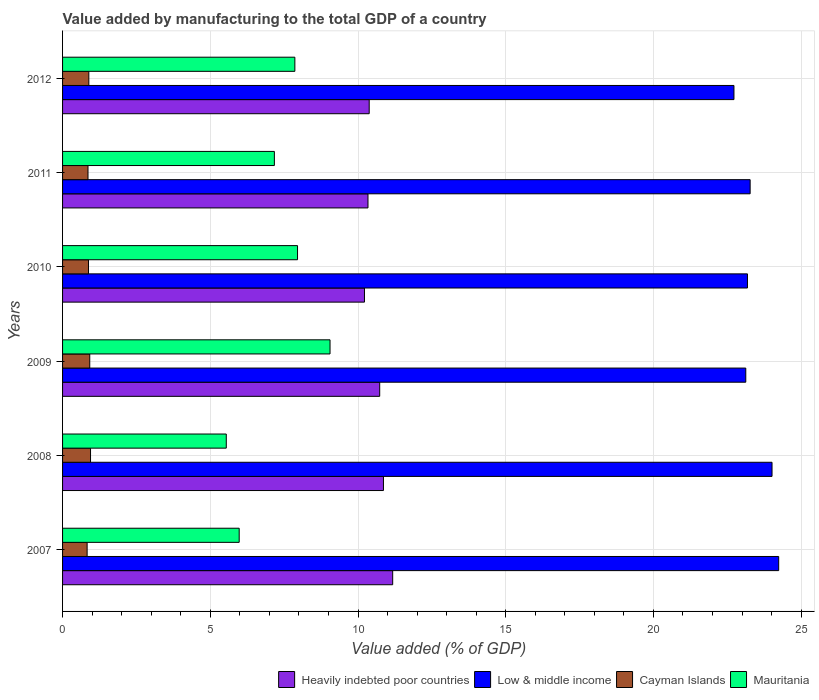How many groups of bars are there?
Your answer should be compact. 6. Are the number of bars on each tick of the Y-axis equal?
Your answer should be compact. Yes. How many bars are there on the 2nd tick from the top?
Ensure brevity in your answer.  4. What is the value added by manufacturing to the total GDP in Low & middle income in 2008?
Offer a very short reply. 24.01. Across all years, what is the maximum value added by manufacturing to the total GDP in Mauritania?
Keep it short and to the point. 9.05. Across all years, what is the minimum value added by manufacturing to the total GDP in Heavily indebted poor countries?
Give a very brief answer. 10.22. What is the total value added by manufacturing to the total GDP in Low & middle income in the graph?
Provide a short and direct response. 140.56. What is the difference between the value added by manufacturing to the total GDP in Mauritania in 2009 and that in 2011?
Your answer should be compact. 1.88. What is the difference between the value added by manufacturing to the total GDP in Low & middle income in 2010 and the value added by manufacturing to the total GDP in Heavily indebted poor countries in 2009?
Offer a very short reply. 12.45. What is the average value added by manufacturing to the total GDP in Low & middle income per year?
Provide a succinct answer. 23.43. In the year 2010, what is the difference between the value added by manufacturing to the total GDP in Cayman Islands and value added by manufacturing to the total GDP in Low & middle income?
Provide a short and direct response. -22.31. What is the ratio of the value added by manufacturing to the total GDP in Heavily indebted poor countries in 2007 to that in 2012?
Give a very brief answer. 1.08. Is the value added by manufacturing to the total GDP in Mauritania in 2007 less than that in 2012?
Your response must be concise. Yes. Is the difference between the value added by manufacturing to the total GDP in Cayman Islands in 2007 and 2010 greater than the difference between the value added by manufacturing to the total GDP in Low & middle income in 2007 and 2010?
Offer a terse response. No. What is the difference between the highest and the second highest value added by manufacturing to the total GDP in Mauritania?
Keep it short and to the point. 1.1. What is the difference between the highest and the lowest value added by manufacturing to the total GDP in Cayman Islands?
Your response must be concise. 0.12. Is it the case that in every year, the sum of the value added by manufacturing to the total GDP in Low & middle income and value added by manufacturing to the total GDP in Heavily indebted poor countries is greater than the sum of value added by manufacturing to the total GDP in Mauritania and value added by manufacturing to the total GDP in Cayman Islands?
Ensure brevity in your answer.  No. What does the 4th bar from the top in 2012 represents?
Keep it short and to the point. Heavily indebted poor countries. What does the 1st bar from the bottom in 2012 represents?
Keep it short and to the point. Heavily indebted poor countries. Are all the bars in the graph horizontal?
Provide a succinct answer. Yes. How many years are there in the graph?
Give a very brief answer. 6. Are the values on the major ticks of X-axis written in scientific E-notation?
Keep it short and to the point. No. Does the graph contain grids?
Your response must be concise. Yes. How are the legend labels stacked?
Provide a succinct answer. Horizontal. What is the title of the graph?
Provide a short and direct response. Value added by manufacturing to the total GDP of a country. Does "Nigeria" appear as one of the legend labels in the graph?
Offer a very short reply. No. What is the label or title of the X-axis?
Your response must be concise. Value added (% of GDP). What is the label or title of the Y-axis?
Offer a very short reply. Years. What is the Value added (% of GDP) of Heavily indebted poor countries in 2007?
Ensure brevity in your answer.  11.17. What is the Value added (% of GDP) in Low & middle income in 2007?
Your response must be concise. 24.24. What is the Value added (% of GDP) of Cayman Islands in 2007?
Give a very brief answer. 0.83. What is the Value added (% of GDP) of Mauritania in 2007?
Ensure brevity in your answer.  5.98. What is the Value added (% of GDP) of Heavily indebted poor countries in 2008?
Your answer should be compact. 10.86. What is the Value added (% of GDP) of Low & middle income in 2008?
Your response must be concise. 24.01. What is the Value added (% of GDP) in Cayman Islands in 2008?
Ensure brevity in your answer.  0.95. What is the Value added (% of GDP) of Mauritania in 2008?
Offer a terse response. 5.54. What is the Value added (% of GDP) of Heavily indebted poor countries in 2009?
Make the answer very short. 10.73. What is the Value added (% of GDP) in Low & middle income in 2009?
Offer a terse response. 23.13. What is the Value added (% of GDP) of Cayman Islands in 2009?
Offer a very short reply. 0.92. What is the Value added (% of GDP) in Mauritania in 2009?
Provide a short and direct response. 9.05. What is the Value added (% of GDP) of Heavily indebted poor countries in 2010?
Your answer should be very brief. 10.22. What is the Value added (% of GDP) of Low & middle income in 2010?
Keep it short and to the point. 23.18. What is the Value added (% of GDP) in Cayman Islands in 2010?
Your answer should be very brief. 0.88. What is the Value added (% of GDP) of Mauritania in 2010?
Provide a short and direct response. 7.95. What is the Value added (% of GDP) in Heavily indebted poor countries in 2011?
Your answer should be very brief. 10.34. What is the Value added (% of GDP) of Low & middle income in 2011?
Ensure brevity in your answer.  23.27. What is the Value added (% of GDP) in Cayman Islands in 2011?
Keep it short and to the point. 0.86. What is the Value added (% of GDP) of Mauritania in 2011?
Give a very brief answer. 7.17. What is the Value added (% of GDP) of Heavily indebted poor countries in 2012?
Your answer should be very brief. 10.38. What is the Value added (% of GDP) of Low & middle income in 2012?
Give a very brief answer. 22.73. What is the Value added (% of GDP) of Cayman Islands in 2012?
Provide a succinct answer. 0.89. What is the Value added (% of GDP) of Mauritania in 2012?
Your answer should be very brief. 7.86. Across all years, what is the maximum Value added (% of GDP) in Heavily indebted poor countries?
Your answer should be compact. 11.17. Across all years, what is the maximum Value added (% of GDP) in Low & middle income?
Offer a terse response. 24.24. Across all years, what is the maximum Value added (% of GDP) in Cayman Islands?
Provide a succinct answer. 0.95. Across all years, what is the maximum Value added (% of GDP) of Mauritania?
Offer a terse response. 9.05. Across all years, what is the minimum Value added (% of GDP) of Heavily indebted poor countries?
Your response must be concise. 10.22. Across all years, what is the minimum Value added (% of GDP) of Low & middle income?
Make the answer very short. 22.73. Across all years, what is the minimum Value added (% of GDP) in Cayman Islands?
Your response must be concise. 0.83. Across all years, what is the minimum Value added (% of GDP) in Mauritania?
Your answer should be compact. 5.54. What is the total Value added (% of GDP) in Heavily indebted poor countries in the graph?
Ensure brevity in your answer.  63.71. What is the total Value added (% of GDP) of Low & middle income in the graph?
Keep it short and to the point. 140.56. What is the total Value added (% of GDP) of Cayman Islands in the graph?
Make the answer very short. 5.33. What is the total Value added (% of GDP) of Mauritania in the graph?
Keep it short and to the point. 43.56. What is the difference between the Value added (% of GDP) in Heavily indebted poor countries in 2007 and that in 2008?
Make the answer very short. 0.31. What is the difference between the Value added (% of GDP) in Low & middle income in 2007 and that in 2008?
Your answer should be compact. 0.23. What is the difference between the Value added (% of GDP) in Cayman Islands in 2007 and that in 2008?
Ensure brevity in your answer.  -0.12. What is the difference between the Value added (% of GDP) in Mauritania in 2007 and that in 2008?
Your answer should be very brief. 0.44. What is the difference between the Value added (% of GDP) in Heavily indebted poor countries in 2007 and that in 2009?
Ensure brevity in your answer.  0.44. What is the difference between the Value added (% of GDP) in Low & middle income in 2007 and that in 2009?
Ensure brevity in your answer.  1.11. What is the difference between the Value added (% of GDP) in Cayman Islands in 2007 and that in 2009?
Make the answer very short. -0.09. What is the difference between the Value added (% of GDP) in Mauritania in 2007 and that in 2009?
Your answer should be compact. -3.08. What is the difference between the Value added (% of GDP) in Heavily indebted poor countries in 2007 and that in 2010?
Your answer should be compact. 0.96. What is the difference between the Value added (% of GDP) in Low & middle income in 2007 and that in 2010?
Keep it short and to the point. 1.06. What is the difference between the Value added (% of GDP) in Cayman Islands in 2007 and that in 2010?
Keep it short and to the point. -0.05. What is the difference between the Value added (% of GDP) in Mauritania in 2007 and that in 2010?
Offer a terse response. -1.97. What is the difference between the Value added (% of GDP) of Heavily indebted poor countries in 2007 and that in 2011?
Offer a very short reply. 0.84. What is the difference between the Value added (% of GDP) in Low & middle income in 2007 and that in 2011?
Ensure brevity in your answer.  0.97. What is the difference between the Value added (% of GDP) of Cayman Islands in 2007 and that in 2011?
Your response must be concise. -0.03. What is the difference between the Value added (% of GDP) of Mauritania in 2007 and that in 2011?
Give a very brief answer. -1.19. What is the difference between the Value added (% of GDP) of Heavily indebted poor countries in 2007 and that in 2012?
Offer a terse response. 0.8. What is the difference between the Value added (% of GDP) in Low & middle income in 2007 and that in 2012?
Provide a short and direct response. 1.51. What is the difference between the Value added (% of GDP) of Cayman Islands in 2007 and that in 2012?
Offer a very short reply. -0.06. What is the difference between the Value added (% of GDP) of Mauritania in 2007 and that in 2012?
Your answer should be compact. -1.88. What is the difference between the Value added (% of GDP) in Heavily indebted poor countries in 2008 and that in 2009?
Provide a succinct answer. 0.13. What is the difference between the Value added (% of GDP) of Low & middle income in 2008 and that in 2009?
Keep it short and to the point. 0.89. What is the difference between the Value added (% of GDP) of Cayman Islands in 2008 and that in 2009?
Give a very brief answer. 0.03. What is the difference between the Value added (% of GDP) in Mauritania in 2008 and that in 2009?
Provide a succinct answer. -3.51. What is the difference between the Value added (% of GDP) in Heavily indebted poor countries in 2008 and that in 2010?
Give a very brief answer. 0.64. What is the difference between the Value added (% of GDP) in Low & middle income in 2008 and that in 2010?
Your answer should be very brief. 0.83. What is the difference between the Value added (% of GDP) of Cayman Islands in 2008 and that in 2010?
Provide a succinct answer. 0.07. What is the difference between the Value added (% of GDP) of Mauritania in 2008 and that in 2010?
Keep it short and to the point. -2.41. What is the difference between the Value added (% of GDP) in Heavily indebted poor countries in 2008 and that in 2011?
Your answer should be compact. 0.52. What is the difference between the Value added (% of GDP) of Low & middle income in 2008 and that in 2011?
Provide a succinct answer. 0.74. What is the difference between the Value added (% of GDP) of Cayman Islands in 2008 and that in 2011?
Ensure brevity in your answer.  0.09. What is the difference between the Value added (% of GDP) in Mauritania in 2008 and that in 2011?
Ensure brevity in your answer.  -1.63. What is the difference between the Value added (% of GDP) of Heavily indebted poor countries in 2008 and that in 2012?
Ensure brevity in your answer.  0.48. What is the difference between the Value added (% of GDP) in Low & middle income in 2008 and that in 2012?
Provide a short and direct response. 1.29. What is the difference between the Value added (% of GDP) of Cayman Islands in 2008 and that in 2012?
Your answer should be very brief. 0.06. What is the difference between the Value added (% of GDP) in Mauritania in 2008 and that in 2012?
Give a very brief answer. -2.32. What is the difference between the Value added (% of GDP) in Heavily indebted poor countries in 2009 and that in 2010?
Provide a succinct answer. 0.52. What is the difference between the Value added (% of GDP) in Low & middle income in 2009 and that in 2010?
Offer a terse response. -0.06. What is the difference between the Value added (% of GDP) in Cayman Islands in 2009 and that in 2010?
Keep it short and to the point. 0.04. What is the difference between the Value added (% of GDP) in Mauritania in 2009 and that in 2010?
Offer a terse response. 1.1. What is the difference between the Value added (% of GDP) of Heavily indebted poor countries in 2009 and that in 2011?
Keep it short and to the point. 0.4. What is the difference between the Value added (% of GDP) of Low & middle income in 2009 and that in 2011?
Offer a terse response. -0.15. What is the difference between the Value added (% of GDP) in Cayman Islands in 2009 and that in 2011?
Your answer should be very brief. 0.06. What is the difference between the Value added (% of GDP) in Mauritania in 2009 and that in 2011?
Your answer should be compact. 1.88. What is the difference between the Value added (% of GDP) in Heavily indebted poor countries in 2009 and that in 2012?
Provide a short and direct response. 0.36. What is the difference between the Value added (% of GDP) in Low & middle income in 2009 and that in 2012?
Offer a very short reply. 0.4. What is the difference between the Value added (% of GDP) in Cayman Islands in 2009 and that in 2012?
Offer a very short reply. 0.03. What is the difference between the Value added (% of GDP) of Mauritania in 2009 and that in 2012?
Offer a terse response. 1.19. What is the difference between the Value added (% of GDP) of Heavily indebted poor countries in 2010 and that in 2011?
Ensure brevity in your answer.  -0.12. What is the difference between the Value added (% of GDP) in Low & middle income in 2010 and that in 2011?
Offer a very short reply. -0.09. What is the difference between the Value added (% of GDP) of Cayman Islands in 2010 and that in 2011?
Keep it short and to the point. 0.02. What is the difference between the Value added (% of GDP) of Mauritania in 2010 and that in 2011?
Ensure brevity in your answer.  0.78. What is the difference between the Value added (% of GDP) of Heavily indebted poor countries in 2010 and that in 2012?
Ensure brevity in your answer.  -0.16. What is the difference between the Value added (% of GDP) in Low & middle income in 2010 and that in 2012?
Give a very brief answer. 0.46. What is the difference between the Value added (% of GDP) in Cayman Islands in 2010 and that in 2012?
Give a very brief answer. -0.01. What is the difference between the Value added (% of GDP) of Mauritania in 2010 and that in 2012?
Give a very brief answer. 0.09. What is the difference between the Value added (% of GDP) in Heavily indebted poor countries in 2011 and that in 2012?
Your response must be concise. -0.04. What is the difference between the Value added (% of GDP) in Low & middle income in 2011 and that in 2012?
Keep it short and to the point. 0.55. What is the difference between the Value added (% of GDP) in Cayman Islands in 2011 and that in 2012?
Provide a short and direct response. -0.03. What is the difference between the Value added (% of GDP) in Mauritania in 2011 and that in 2012?
Make the answer very short. -0.69. What is the difference between the Value added (% of GDP) in Heavily indebted poor countries in 2007 and the Value added (% of GDP) in Low & middle income in 2008?
Give a very brief answer. -12.84. What is the difference between the Value added (% of GDP) in Heavily indebted poor countries in 2007 and the Value added (% of GDP) in Cayman Islands in 2008?
Provide a succinct answer. 10.23. What is the difference between the Value added (% of GDP) of Heavily indebted poor countries in 2007 and the Value added (% of GDP) of Mauritania in 2008?
Your response must be concise. 5.63. What is the difference between the Value added (% of GDP) in Low & middle income in 2007 and the Value added (% of GDP) in Cayman Islands in 2008?
Make the answer very short. 23.29. What is the difference between the Value added (% of GDP) in Low & middle income in 2007 and the Value added (% of GDP) in Mauritania in 2008?
Offer a terse response. 18.7. What is the difference between the Value added (% of GDP) in Cayman Islands in 2007 and the Value added (% of GDP) in Mauritania in 2008?
Offer a very short reply. -4.71. What is the difference between the Value added (% of GDP) in Heavily indebted poor countries in 2007 and the Value added (% of GDP) in Low & middle income in 2009?
Provide a succinct answer. -11.95. What is the difference between the Value added (% of GDP) of Heavily indebted poor countries in 2007 and the Value added (% of GDP) of Cayman Islands in 2009?
Your response must be concise. 10.25. What is the difference between the Value added (% of GDP) in Heavily indebted poor countries in 2007 and the Value added (% of GDP) in Mauritania in 2009?
Offer a very short reply. 2.12. What is the difference between the Value added (% of GDP) in Low & middle income in 2007 and the Value added (% of GDP) in Cayman Islands in 2009?
Your answer should be compact. 23.32. What is the difference between the Value added (% of GDP) in Low & middle income in 2007 and the Value added (% of GDP) in Mauritania in 2009?
Make the answer very short. 15.19. What is the difference between the Value added (% of GDP) of Cayman Islands in 2007 and the Value added (% of GDP) of Mauritania in 2009?
Give a very brief answer. -8.22. What is the difference between the Value added (% of GDP) in Heavily indebted poor countries in 2007 and the Value added (% of GDP) in Low & middle income in 2010?
Keep it short and to the point. -12.01. What is the difference between the Value added (% of GDP) in Heavily indebted poor countries in 2007 and the Value added (% of GDP) in Cayman Islands in 2010?
Your answer should be very brief. 10.3. What is the difference between the Value added (% of GDP) of Heavily indebted poor countries in 2007 and the Value added (% of GDP) of Mauritania in 2010?
Your answer should be compact. 3.22. What is the difference between the Value added (% of GDP) in Low & middle income in 2007 and the Value added (% of GDP) in Cayman Islands in 2010?
Your answer should be very brief. 23.36. What is the difference between the Value added (% of GDP) of Low & middle income in 2007 and the Value added (% of GDP) of Mauritania in 2010?
Ensure brevity in your answer.  16.29. What is the difference between the Value added (% of GDP) of Cayman Islands in 2007 and the Value added (% of GDP) of Mauritania in 2010?
Give a very brief answer. -7.12. What is the difference between the Value added (% of GDP) in Heavily indebted poor countries in 2007 and the Value added (% of GDP) in Low & middle income in 2011?
Keep it short and to the point. -12.1. What is the difference between the Value added (% of GDP) of Heavily indebted poor countries in 2007 and the Value added (% of GDP) of Cayman Islands in 2011?
Give a very brief answer. 10.31. What is the difference between the Value added (% of GDP) in Heavily indebted poor countries in 2007 and the Value added (% of GDP) in Mauritania in 2011?
Your answer should be very brief. 4.01. What is the difference between the Value added (% of GDP) in Low & middle income in 2007 and the Value added (% of GDP) in Cayman Islands in 2011?
Provide a succinct answer. 23.38. What is the difference between the Value added (% of GDP) of Low & middle income in 2007 and the Value added (% of GDP) of Mauritania in 2011?
Offer a terse response. 17.07. What is the difference between the Value added (% of GDP) of Cayman Islands in 2007 and the Value added (% of GDP) of Mauritania in 2011?
Provide a succinct answer. -6.34. What is the difference between the Value added (% of GDP) of Heavily indebted poor countries in 2007 and the Value added (% of GDP) of Low & middle income in 2012?
Give a very brief answer. -11.55. What is the difference between the Value added (% of GDP) in Heavily indebted poor countries in 2007 and the Value added (% of GDP) in Cayman Islands in 2012?
Provide a succinct answer. 10.29. What is the difference between the Value added (% of GDP) in Heavily indebted poor countries in 2007 and the Value added (% of GDP) in Mauritania in 2012?
Ensure brevity in your answer.  3.31. What is the difference between the Value added (% of GDP) of Low & middle income in 2007 and the Value added (% of GDP) of Cayman Islands in 2012?
Provide a short and direct response. 23.35. What is the difference between the Value added (% of GDP) in Low & middle income in 2007 and the Value added (% of GDP) in Mauritania in 2012?
Offer a terse response. 16.38. What is the difference between the Value added (% of GDP) in Cayman Islands in 2007 and the Value added (% of GDP) in Mauritania in 2012?
Your response must be concise. -7.03. What is the difference between the Value added (% of GDP) in Heavily indebted poor countries in 2008 and the Value added (% of GDP) in Low & middle income in 2009?
Offer a very short reply. -12.26. What is the difference between the Value added (% of GDP) of Heavily indebted poor countries in 2008 and the Value added (% of GDP) of Cayman Islands in 2009?
Offer a very short reply. 9.94. What is the difference between the Value added (% of GDP) of Heavily indebted poor countries in 2008 and the Value added (% of GDP) of Mauritania in 2009?
Give a very brief answer. 1.81. What is the difference between the Value added (% of GDP) of Low & middle income in 2008 and the Value added (% of GDP) of Cayman Islands in 2009?
Your answer should be very brief. 23.09. What is the difference between the Value added (% of GDP) of Low & middle income in 2008 and the Value added (% of GDP) of Mauritania in 2009?
Your answer should be very brief. 14.96. What is the difference between the Value added (% of GDP) in Cayman Islands in 2008 and the Value added (% of GDP) in Mauritania in 2009?
Ensure brevity in your answer.  -8.11. What is the difference between the Value added (% of GDP) of Heavily indebted poor countries in 2008 and the Value added (% of GDP) of Low & middle income in 2010?
Provide a short and direct response. -12.32. What is the difference between the Value added (% of GDP) in Heavily indebted poor countries in 2008 and the Value added (% of GDP) in Cayman Islands in 2010?
Offer a very short reply. 9.98. What is the difference between the Value added (% of GDP) in Heavily indebted poor countries in 2008 and the Value added (% of GDP) in Mauritania in 2010?
Provide a succinct answer. 2.91. What is the difference between the Value added (% of GDP) of Low & middle income in 2008 and the Value added (% of GDP) of Cayman Islands in 2010?
Keep it short and to the point. 23.14. What is the difference between the Value added (% of GDP) in Low & middle income in 2008 and the Value added (% of GDP) in Mauritania in 2010?
Make the answer very short. 16.06. What is the difference between the Value added (% of GDP) of Cayman Islands in 2008 and the Value added (% of GDP) of Mauritania in 2010?
Your answer should be very brief. -7.01. What is the difference between the Value added (% of GDP) of Heavily indebted poor countries in 2008 and the Value added (% of GDP) of Low & middle income in 2011?
Offer a very short reply. -12.41. What is the difference between the Value added (% of GDP) of Heavily indebted poor countries in 2008 and the Value added (% of GDP) of Cayman Islands in 2011?
Make the answer very short. 10. What is the difference between the Value added (% of GDP) of Heavily indebted poor countries in 2008 and the Value added (% of GDP) of Mauritania in 2011?
Your response must be concise. 3.69. What is the difference between the Value added (% of GDP) in Low & middle income in 2008 and the Value added (% of GDP) in Cayman Islands in 2011?
Your response must be concise. 23.15. What is the difference between the Value added (% of GDP) of Low & middle income in 2008 and the Value added (% of GDP) of Mauritania in 2011?
Make the answer very short. 16.84. What is the difference between the Value added (% of GDP) in Cayman Islands in 2008 and the Value added (% of GDP) in Mauritania in 2011?
Ensure brevity in your answer.  -6.22. What is the difference between the Value added (% of GDP) in Heavily indebted poor countries in 2008 and the Value added (% of GDP) in Low & middle income in 2012?
Your response must be concise. -11.86. What is the difference between the Value added (% of GDP) of Heavily indebted poor countries in 2008 and the Value added (% of GDP) of Cayman Islands in 2012?
Ensure brevity in your answer.  9.97. What is the difference between the Value added (% of GDP) in Heavily indebted poor countries in 2008 and the Value added (% of GDP) in Mauritania in 2012?
Keep it short and to the point. 3. What is the difference between the Value added (% of GDP) in Low & middle income in 2008 and the Value added (% of GDP) in Cayman Islands in 2012?
Give a very brief answer. 23.12. What is the difference between the Value added (% of GDP) of Low & middle income in 2008 and the Value added (% of GDP) of Mauritania in 2012?
Your response must be concise. 16.15. What is the difference between the Value added (% of GDP) in Cayman Islands in 2008 and the Value added (% of GDP) in Mauritania in 2012?
Provide a short and direct response. -6.92. What is the difference between the Value added (% of GDP) of Heavily indebted poor countries in 2009 and the Value added (% of GDP) of Low & middle income in 2010?
Ensure brevity in your answer.  -12.45. What is the difference between the Value added (% of GDP) of Heavily indebted poor countries in 2009 and the Value added (% of GDP) of Cayman Islands in 2010?
Make the answer very short. 9.86. What is the difference between the Value added (% of GDP) of Heavily indebted poor countries in 2009 and the Value added (% of GDP) of Mauritania in 2010?
Provide a succinct answer. 2.78. What is the difference between the Value added (% of GDP) in Low & middle income in 2009 and the Value added (% of GDP) in Cayman Islands in 2010?
Offer a very short reply. 22.25. What is the difference between the Value added (% of GDP) of Low & middle income in 2009 and the Value added (% of GDP) of Mauritania in 2010?
Your answer should be compact. 15.17. What is the difference between the Value added (% of GDP) in Cayman Islands in 2009 and the Value added (% of GDP) in Mauritania in 2010?
Keep it short and to the point. -7.03. What is the difference between the Value added (% of GDP) of Heavily indebted poor countries in 2009 and the Value added (% of GDP) of Low & middle income in 2011?
Give a very brief answer. -12.54. What is the difference between the Value added (% of GDP) in Heavily indebted poor countries in 2009 and the Value added (% of GDP) in Cayman Islands in 2011?
Your answer should be compact. 9.87. What is the difference between the Value added (% of GDP) in Heavily indebted poor countries in 2009 and the Value added (% of GDP) in Mauritania in 2011?
Offer a very short reply. 3.57. What is the difference between the Value added (% of GDP) in Low & middle income in 2009 and the Value added (% of GDP) in Cayman Islands in 2011?
Your answer should be compact. 22.27. What is the difference between the Value added (% of GDP) in Low & middle income in 2009 and the Value added (% of GDP) in Mauritania in 2011?
Provide a short and direct response. 15.96. What is the difference between the Value added (% of GDP) of Cayman Islands in 2009 and the Value added (% of GDP) of Mauritania in 2011?
Your response must be concise. -6.25. What is the difference between the Value added (% of GDP) of Heavily indebted poor countries in 2009 and the Value added (% of GDP) of Low & middle income in 2012?
Your answer should be compact. -11.99. What is the difference between the Value added (% of GDP) in Heavily indebted poor countries in 2009 and the Value added (% of GDP) in Cayman Islands in 2012?
Offer a very short reply. 9.85. What is the difference between the Value added (% of GDP) in Heavily indebted poor countries in 2009 and the Value added (% of GDP) in Mauritania in 2012?
Give a very brief answer. 2.87. What is the difference between the Value added (% of GDP) of Low & middle income in 2009 and the Value added (% of GDP) of Cayman Islands in 2012?
Make the answer very short. 22.24. What is the difference between the Value added (% of GDP) in Low & middle income in 2009 and the Value added (% of GDP) in Mauritania in 2012?
Provide a succinct answer. 15.26. What is the difference between the Value added (% of GDP) of Cayman Islands in 2009 and the Value added (% of GDP) of Mauritania in 2012?
Ensure brevity in your answer.  -6.94. What is the difference between the Value added (% of GDP) of Heavily indebted poor countries in 2010 and the Value added (% of GDP) of Low & middle income in 2011?
Offer a terse response. -13.05. What is the difference between the Value added (% of GDP) of Heavily indebted poor countries in 2010 and the Value added (% of GDP) of Cayman Islands in 2011?
Your answer should be very brief. 9.36. What is the difference between the Value added (% of GDP) of Heavily indebted poor countries in 2010 and the Value added (% of GDP) of Mauritania in 2011?
Provide a short and direct response. 3.05. What is the difference between the Value added (% of GDP) of Low & middle income in 2010 and the Value added (% of GDP) of Cayman Islands in 2011?
Provide a succinct answer. 22.32. What is the difference between the Value added (% of GDP) of Low & middle income in 2010 and the Value added (% of GDP) of Mauritania in 2011?
Your answer should be compact. 16.01. What is the difference between the Value added (% of GDP) of Cayman Islands in 2010 and the Value added (% of GDP) of Mauritania in 2011?
Provide a succinct answer. -6.29. What is the difference between the Value added (% of GDP) in Heavily indebted poor countries in 2010 and the Value added (% of GDP) in Low & middle income in 2012?
Provide a succinct answer. -12.51. What is the difference between the Value added (% of GDP) of Heavily indebted poor countries in 2010 and the Value added (% of GDP) of Cayman Islands in 2012?
Give a very brief answer. 9.33. What is the difference between the Value added (% of GDP) of Heavily indebted poor countries in 2010 and the Value added (% of GDP) of Mauritania in 2012?
Your answer should be compact. 2.36. What is the difference between the Value added (% of GDP) in Low & middle income in 2010 and the Value added (% of GDP) in Cayman Islands in 2012?
Ensure brevity in your answer.  22.29. What is the difference between the Value added (% of GDP) in Low & middle income in 2010 and the Value added (% of GDP) in Mauritania in 2012?
Offer a terse response. 15.32. What is the difference between the Value added (% of GDP) in Cayman Islands in 2010 and the Value added (% of GDP) in Mauritania in 2012?
Keep it short and to the point. -6.99. What is the difference between the Value added (% of GDP) in Heavily indebted poor countries in 2011 and the Value added (% of GDP) in Low & middle income in 2012?
Your answer should be very brief. -12.39. What is the difference between the Value added (% of GDP) of Heavily indebted poor countries in 2011 and the Value added (% of GDP) of Cayman Islands in 2012?
Ensure brevity in your answer.  9.45. What is the difference between the Value added (% of GDP) of Heavily indebted poor countries in 2011 and the Value added (% of GDP) of Mauritania in 2012?
Make the answer very short. 2.48. What is the difference between the Value added (% of GDP) in Low & middle income in 2011 and the Value added (% of GDP) in Cayman Islands in 2012?
Keep it short and to the point. 22.38. What is the difference between the Value added (% of GDP) in Low & middle income in 2011 and the Value added (% of GDP) in Mauritania in 2012?
Your answer should be compact. 15.41. What is the difference between the Value added (% of GDP) of Cayman Islands in 2011 and the Value added (% of GDP) of Mauritania in 2012?
Provide a short and direct response. -7. What is the average Value added (% of GDP) in Heavily indebted poor countries per year?
Your response must be concise. 10.62. What is the average Value added (% of GDP) in Low & middle income per year?
Give a very brief answer. 23.43. What is the average Value added (% of GDP) of Cayman Islands per year?
Keep it short and to the point. 0.89. What is the average Value added (% of GDP) of Mauritania per year?
Make the answer very short. 7.26. In the year 2007, what is the difference between the Value added (% of GDP) in Heavily indebted poor countries and Value added (% of GDP) in Low & middle income?
Make the answer very short. -13.07. In the year 2007, what is the difference between the Value added (% of GDP) in Heavily indebted poor countries and Value added (% of GDP) in Cayman Islands?
Provide a succinct answer. 10.34. In the year 2007, what is the difference between the Value added (% of GDP) in Heavily indebted poor countries and Value added (% of GDP) in Mauritania?
Give a very brief answer. 5.2. In the year 2007, what is the difference between the Value added (% of GDP) in Low & middle income and Value added (% of GDP) in Cayman Islands?
Offer a very short reply. 23.41. In the year 2007, what is the difference between the Value added (% of GDP) of Low & middle income and Value added (% of GDP) of Mauritania?
Keep it short and to the point. 18.26. In the year 2007, what is the difference between the Value added (% of GDP) in Cayman Islands and Value added (% of GDP) in Mauritania?
Offer a very short reply. -5.15. In the year 2008, what is the difference between the Value added (% of GDP) of Heavily indebted poor countries and Value added (% of GDP) of Low & middle income?
Your response must be concise. -13.15. In the year 2008, what is the difference between the Value added (% of GDP) in Heavily indebted poor countries and Value added (% of GDP) in Cayman Islands?
Provide a short and direct response. 9.91. In the year 2008, what is the difference between the Value added (% of GDP) of Heavily indebted poor countries and Value added (% of GDP) of Mauritania?
Keep it short and to the point. 5.32. In the year 2008, what is the difference between the Value added (% of GDP) of Low & middle income and Value added (% of GDP) of Cayman Islands?
Offer a very short reply. 23.07. In the year 2008, what is the difference between the Value added (% of GDP) of Low & middle income and Value added (% of GDP) of Mauritania?
Keep it short and to the point. 18.47. In the year 2008, what is the difference between the Value added (% of GDP) of Cayman Islands and Value added (% of GDP) of Mauritania?
Provide a short and direct response. -4.59. In the year 2009, what is the difference between the Value added (% of GDP) in Heavily indebted poor countries and Value added (% of GDP) in Low & middle income?
Offer a very short reply. -12.39. In the year 2009, what is the difference between the Value added (% of GDP) in Heavily indebted poor countries and Value added (% of GDP) in Cayman Islands?
Offer a terse response. 9.81. In the year 2009, what is the difference between the Value added (% of GDP) of Heavily indebted poor countries and Value added (% of GDP) of Mauritania?
Offer a very short reply. 1.68. In the year 2009, what is the difference between the Value added (% of GDP) of Low & middle income and Value added (% of GDP) of Cayman Islands?
Make the answer very short. 22.21. In the year 2009, what is the difference between the Value added (% of GDP) in Low & middle income and Value added (% of GDP) in Mauritania?
Provide a short and direct response. 14.07. In the year 2009, what is the difference between the Value added (% of GDP) of Cayman Islands and Value added (% of GDP) of Mauritania?
Your answer should be compact. -8.13. In the year 2010, what is the difference between the Value added (% of GDP) in Heavily indebted poor countries and Value added (% of GDP) in Low & middle income?
Offer a terse response. -12.96. In the year 2010, what is the difference between the Value added (% of GDP) of Heavily indebted poor countries and Value added (% of GDP) of Cayman Islands?
Make the answer very short. 9.34. In the year 2010, what is the difference between the Value added (% of GDP) in Heavily indebted poor countries and Value added (% of GDP) in Mauritania?
Offer a terse response. 2.27. In the year 2010, what is the difference between the Value added (% of GDP) in Low & middle income and Value added (% of GDP) in Cayman Islands?
Keep it short and to the point. 22.31. In the year 2010, what is the difference between the Value added (% of GDP) in Low & middle income and Value added (% of GDP) in Mauritania?
Offer a terse response. 15.23. In the year 2010, what is the difference between the Value added (% of GDP) in Cayman Islands and Value added (% of GDP) in Mauritania?
Keep it short and to the point. -7.08. In the year 2011, what is the difference between the Value added (% of GDP) of Heavily indebted poor countries and Value added (% of GDP) of Low & middle income?
Provide a short and direct response. -12.94. In the year 2011, what is the difference between the Value added (% of GDP) of Heavily indebted poor countries and Value added (% of GDP) of Cayman Islands?
Provide a short and direct response. 9.48. In the year 2011, what is the difference between the Value added (% of GDP) in Heavily indebted poor countries and Value added (% of GDP) in Mauritania?
Keep it short and to the point. 3.17. In the year 2011, what is the difference between the Value added (% of GDP) of Low & middle income and Value added (% of GDP) of Cayman Islands?
Your response must be concise. 22.41. In the year 2011, what is the difference between the Value added (% of GDP) in Low & middle income and Value added (% of GDP) in Mauritania?
Provide a succinct answer. 16.1. In the year 2011, what is the difference between the Value added (% of GDP) of Cayman Islands and Value added (% of GDP) of Mauritania?
Your answer should be very brief. -6.31. In the year 2012, what is the difference between the Value added (% of GDP) in Heavily indebted poor countries and Value added (% of GDP) in Low & middle income?
Give a very brief answer. -12.35. In the year 2012, what is the difference between the Value added (% of GDP) in Heavily indebted poor countries and Value added (% of GDP) in Cayman Islands?
Keep it short and to the point. 9.49. In the year 2012, what is the difference between the Value added (% of GDP) of Heavily indebted poor countries and Value added (% of GDP) of Mauritania?
Provide a short and direct response. 2.52. In the year 2012, what is the difference between the Value added (% of GDP) of Low & middle income and Value added (% of GDP) of Cayman Islands?
Ensure brevity in your answer.  21.84. In the year 2012, what is the difference between the Value added (% of GDP) in Low & middle income and Value added (% of GDP) in Mauritania?
Your response must be concise. 14.86. In the year 2012, what is the difference between the Value added (% of GDP) in Cayman Islands and Value added (% of GDP) in Mauritania?
Your answer should be compact. -6.97. What is the ratio of the Value added (% of GDP) in Heavily indebted poor countries in 2007 to that in 2008?
Provide a succinct answer. 1.03. What is the ratio of the Value added (% of GDP) in Low & middle income in 2007 to that in 2008?
Keep it short and to the point. 1.01. What is the ratio of the Value added (% of GDP) of Cayman Islands in 2007 to that in 2008?
Offer a very short reply. 0.88. What is the ratio of the Value added (% of GDP) of Mauritania in 2007 to that in 2008?
Ensure brevity in your answer.  1.08. What is the ratio of the Value added (% of GDP) in Heavily indebted poor countries in 2007 to that in 2009?
Ensure brevity in your answer.  1.04. What is the ratio of the Value added (% of GDP) of Low & middle income in 2007 to that in 2009?
Your answer should be compact. 1.05. What is the ratio of the Value added (% of GDP) in Cayman Islands in 2007 to that in 2009?
Give a very brief answer. 0.9. What is the ratio of the Value added (% of GDP) in Mauritania in 2007 to that in 2009?
Make the answer very short. 0.66. What is the ratio of the Value added (% of GDP) of Heavily indebted poor countries in 2007 to that in 2010?
Ensure brevity in your answer.  1.09. What is the ratio of the Value added (% of GDP) of Low & middle income in 2007 to that in 2010?
Your response must be concise. 1.05. What is the ratio of the Value added (% of GDP) in Cayman Islands in 2007 to that in 2010?
Ensure brevity in your answer.  0.95. What is the ratio of the Value added (% of GDP) in Mauritania in 2007 to that in 2010?
Offer a terse response. 0.75. What is the ratio of the Value added (% of GDP) in Heavily indebted poor countries in 2007 to that in 2011?
Ensure brevity in your answer.  1.08. What is the ratio of the Value added (% of GDP) in Low & middle income in 2007 to that in 2011?
Offer a terse response. 1.04. What is the ratio of the Value added (% of GDP) of Cayman Islands in 2007 to that in 2011?
Make the answer very short. 0.97. What is the ratio of the Value added (% of GDP) of Mauritania in 2007 to that in 2011?
Provide a succinct answer. 0.83. What is the ratio of the Value added (% of GDP) in Heavily indebted poor countries in 2007 to that in 2012?
Make the answer very short. 1.08. What is the ratio of the Value added (% of GDP) of Low & middle income in 2007 to that in 2012?
Your answer should be compact. 1.07. What is the ratio of the Value added (% of GDP) of Cayman Islands in 2007 to that in 2012?
Keep it short and to the point. 0.94. What is the ratio of the Value added (% of GDP) in Mauritania in 2007 to that in 2012?
Keep it short and to the point. 0.76. What is the ratio of the Value added (% of GDP) in Heavily indebted poor countries in 2008 to that in 2009?
Your answer should be very brief. 1.01. What is the ratio of the Value added (% of GDP) in Low & middle income in 2008 to that in 2009?
Make the answer very short. 1.04. What is the ratio of the Value added (% of GDP) in Cayman Islands in 2008 to that in 2009?
Offer a terse response. 1.03. What is the ratio of the Value added (% of GDP) in Mauritania in 2008 to that in 2009?
Your answer should be compact. 0.61. What is the ratio of the Value added (% of GDP) of Heavily indebted poor countries in 2008 to that in 2010?
Provide a short and direct response. 1.06. What is the ratio of the Value added (% of GDP) of Low & middle income in 2008 to that in 2010?
Give a very brief answer. 1.04. What is the ratio of the Value added (% of GDP) of Cayman Islands in 2008 to that in 2010?
Your answer should be very brief. 1.08. What is the ratio of the Value added (% of GDP) in Mauritania in 2008 to that in 2010?
Keep it short and to the point. 0.7. What is the ratio of the Value added (% of GDP) of Heavily indebted poor countries in 2008 to that in 2011?
Your answer should be very brief. 1.05. What is the ratio of the Value added (% of GDP) in Low & middle income in 2008 to that in 2011?
Provide a succinct answer. 1.03. What is the ratio of the Value added (% of GDP) of Cayman Islands in 2008 to that in 2011?
Make the answer very short. 1.1. What is the ratio of the Value added (% of GDP) in Mauritania in 2008 to that in 2011?
Offer a terse response. 0.77. What is the ratio of the Value added (% of GDP) of Heavily indebted poor countries in 2008 to that in 2012?
Keep it short and to the point. 1.05. What is the ratio of the Value added (% of GDP) of Low & middle income in 2008 to that in 2012?
Give a very brief answer. 1.06. What is the ratio of the Value added (% of GDP) in Cayman Islands in 2008 to that in 2012?
Your response must be concise. 1.06. What is the ratio of the Value added (% of GDP) of Mauritania in 2008 to that in 2012?
Provide a short and direct response. 0.7. What is the ratio of the Value added (% of GDP) in Heavily indebted poor countries in 2009 to that in 2010?
Provide a short and direct response. 1.05. What is the ratio of the Value added (% of GDP) of Low & middle income in 2009 to that in 2010?
Make the answer very short. 1. What is the ratio of the Value added (% of GDP) in Cayman Islands in 2009 to that in 2010?
Your answer should be very brief. 1.05. What is the ratio of the Value added (% of GDP) of Mauritania in 2009 to that in 2010?
Ensure brevity in your answer.  1.14. What is the ratio of the Value added (% of GDP) in Heavily indebted poor countries in 2009 to that in 2011?
Offer a terse response. 1.04. What is the ratio of the Value added (% of GDP) of Low & middle income in 2009 to that in 2011?
Provide a succinct answer. 0.99. What is the ratio of the Value added (% of GDP) of Cayman Islands in 2009 to that in 2011?
Ensure brevity in your answer.  1.07. What is the ratio of the Value added (% of GDP) in Mauritania in 2009 to that in 2011?
Offer a very short reply. 1.26. What is the ratio of the Value added (% of GDP) of Heavily indebted poor countries in 2009 to that in 2012?
Offer a very short reply. 1.03. What is the ratio of the Value added (% of GDP) in Low & middle income in 2009 to that in 2012?
Keep it short and to the point. 1.02. What is the ratio of the Value added (% of GDP) in Cayman Islands in 2009 to that in 2012?
Make the answer very short. 1.03. What is the ratio of the Value added (% of GDP) in Mauritania in 2009 to that in 2012?
Your answer should be compact. 1.15. What is the ratio of the Value added (% of GDP) in Heavily indebted poor countries in 2010 to that in 2011?
Provide a succinct answer. 0.99. What is the ratio of the Value added (% of GDP) of Cayman Islands in 2010 to that in 2011?
Offer a terse response. 1.02. What is the ratio of the Value added (% of GDP) in Mauritania in 2010 to that in 2011?
Provide a short and direct response. 1.11. What is the ratio of the Value added (% of GDP) of Heavily indebted poor countries in 2010 to that in 2012?
Ensure brevity in your answer.  0.98. What is the ratio of the Value added (% of GDP) of Low & middle income in 2010 to that in 2012?
Your response must be concise. 1.02. What is the ratio of the Value added (% of GDP) of Cayman Islands in 2010 to that in 2012?
Your answer should be compact. 0.99. What is the ratio of the Value added (% of GDP) in Mauritania in 2010 to that in 2012?
Give a very brief answer. 1.01. What is the ratio of the Value added (% of GDP) of Low & middle income in 2011 to that in 2012?
Ensure brevity in your answer.  1.02. What is the ratio of the Value added (% of GDP) of Cayman Islands in 2011 to that in 2012?
Your answer should be very brief. 0.97. What is the ratio of the Value added (% of GDP) of Mauritania in 2011 to that in 2012?
Make the answer very short. 0.91. What is the difference between the highest and the second highest Value added (% of GDP) of Heavily indebted poor countries?
Your answer should be very brief. 0.31. What is the difference between the highest and the second highest Value added (% of GDP) in Low & middle income?
Offer a very short reply. 0.23. What is the difference between the highest and the second highest Value added (% of GDP) in Cayman Islands?
Offer a terse response. 0.03. What is the difference between the highest and the second highest Value added (% of GDP) in Mauritania?
Keep it short and to the point. 1.1. What is the difference between the highest and the lowest Value added (% of GDP) in Heavily indebted poor countries?
Offer a very short reply. 0.96. What is the difference between the highest and the lowest Value added (% of GDP) of Low & middle income?
Make the answer very short. 1.51. What is the difference between the highest and the lowest Value added (% of GDP) of Cayman Islands?
Keep it short and to the point. 0.12. What is the difference between the highest and the lowest Value added (% of GDP) of Mauritania?
Offer a very short reply. 3.51. 